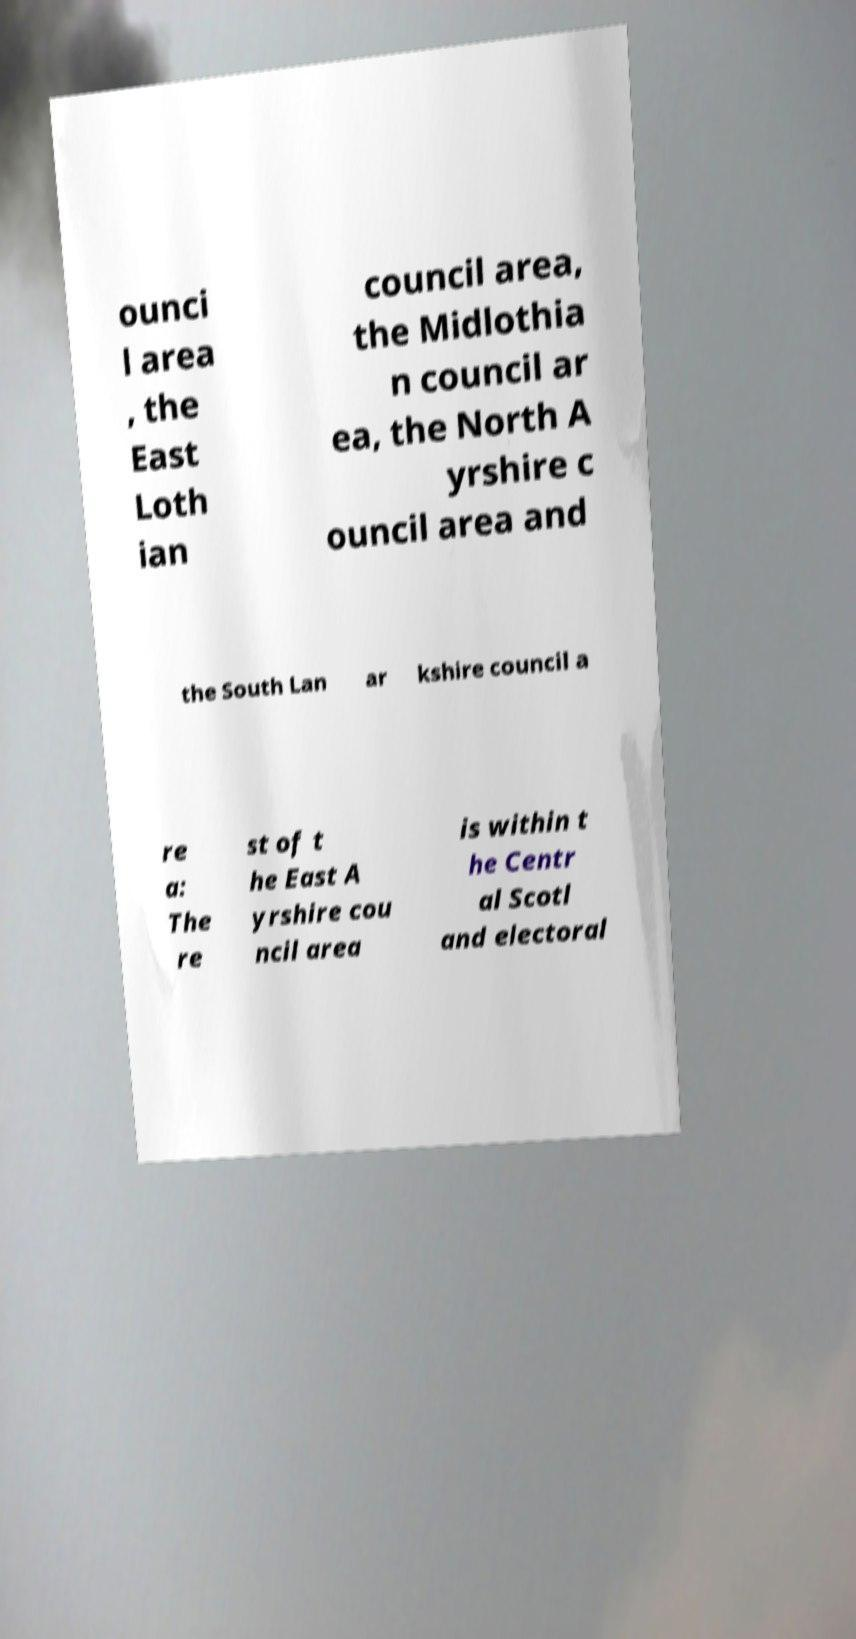Could you assist in decoding the text presented in this image and type it out clearly? ounci l area , the East Loth ian council area, the Midlothia n council ar ea, the North A yrshire c ouncil area and the South Lan ar kshire council a re a: The re st of t he East A yrshire cou ncil area is within t he Centr al Scotl and electoral 